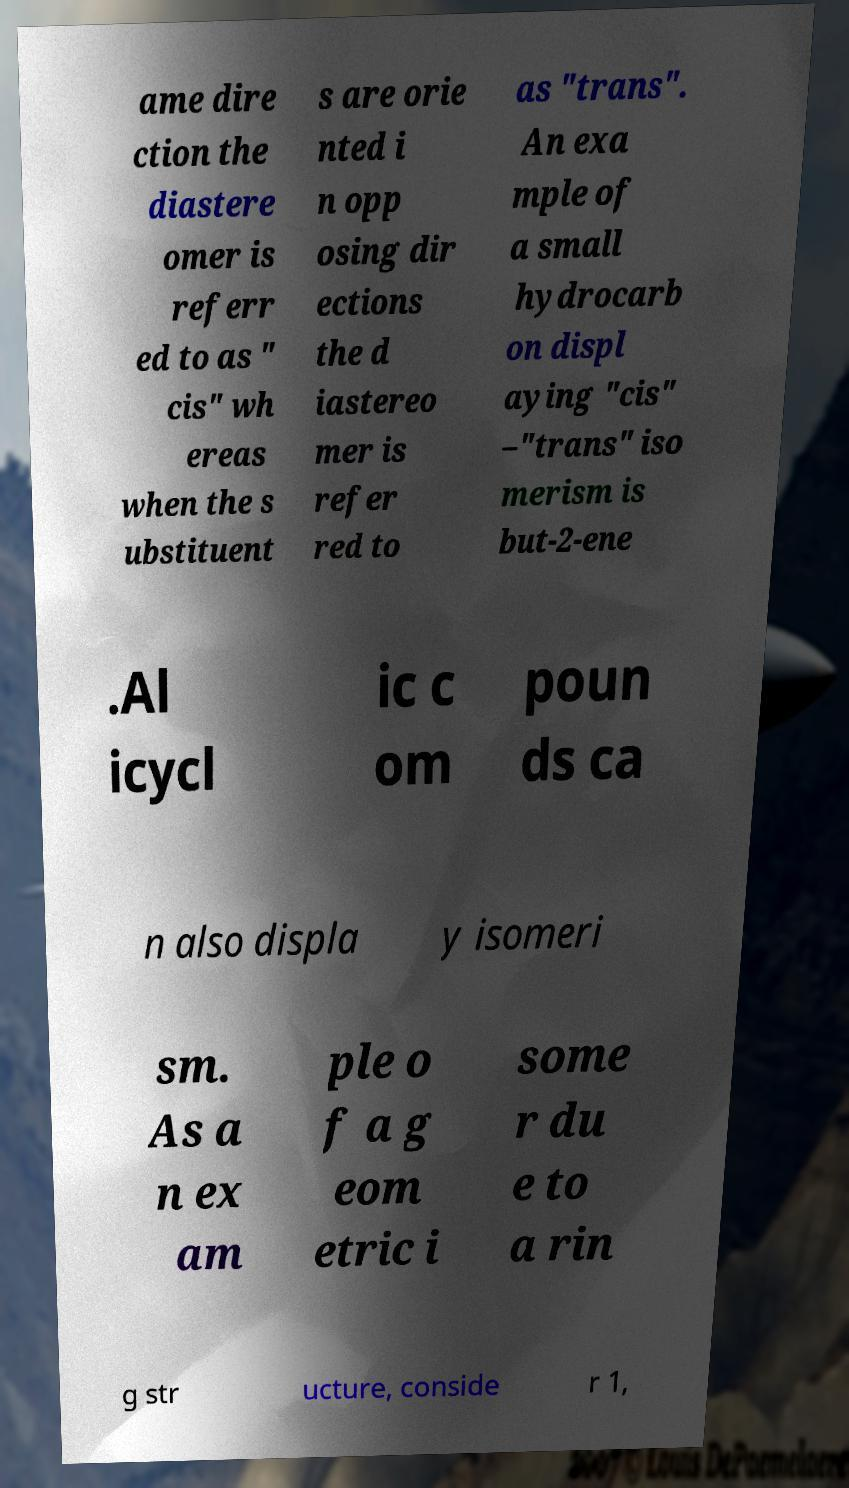Can you read and provide the text displayed in the image?This photo seems to have some interesting text. Can you extract and type it out for me? ame dire ction the diastere omer is referr ed to as " cis" wh ereas when the s ubstituent s are orie nted i n opp osing dir ections the d iastereo mer is refer red to as "trans". An exa mple of a small hydrocarb on displ aying "cis" –"trans" iso merism is but-2-ene .Al icycl ic c om poun ds ca n also displa y isomeri sm. As a n ex am ple o f a g eom etric i some r du e to a rin g str ucture, conside r 1, 